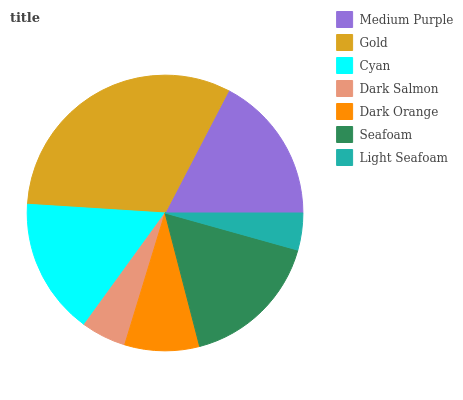Is Light Seafoam the minimum?
Answer yes or no. Yes. Is Gold the maximum?
Answer yes or no. Yes. Is Cyan the minimum?
Answer yes or no. No. Is Cyan the maximum?
Answer yes or no. No. Is Gold greater than Cyan?
Answer yes or no. Yes. Is Cyan less than Gold?
Answer yes or no. Yes. Is Cyan greater than Gold?
Answer yes or no. No. Is Gold less than Cyan?
Answer yes or no. No. Is Cyan the high median?
Answer yes or no. Yes. Is Cyan the low median?
Answer yes or no. Yes. Is Light Seafoam the high median?
Answer yes or no. No. Is Gold the low median?
Answer yes or no. No. 